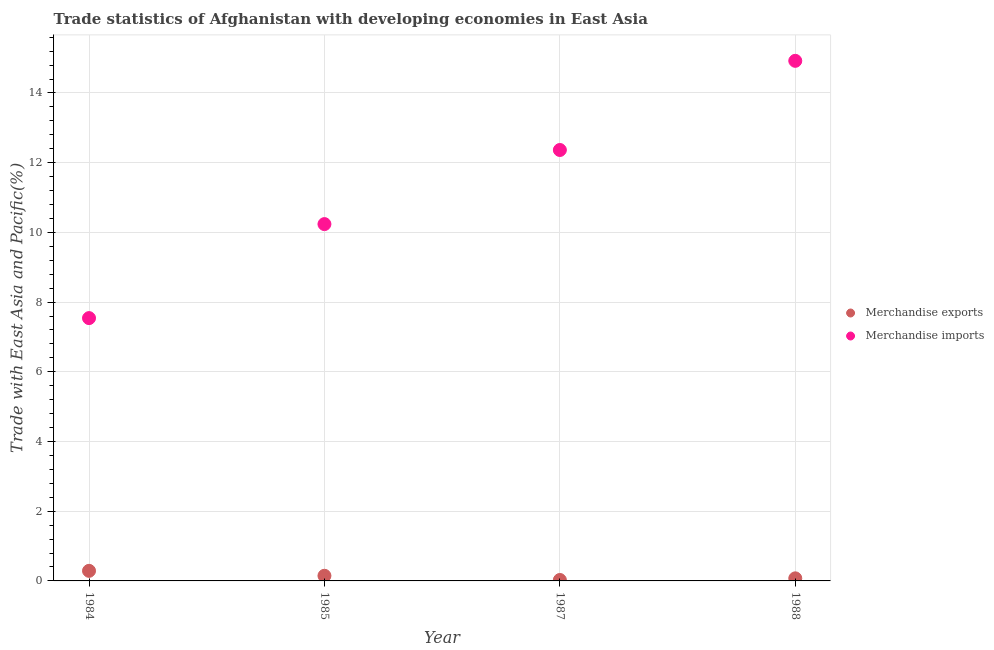How many different coloured dotlines are there?
Your answer should be very brief. 2. What is the merchandise imports in 1985?
Keep it short and to the point. 10.24. Across all years, what is the maximum merchandise exports?
Offer a terse response. 0.29. Across all years, what is the minimum merchandise imports?
Offer a very short reply. 7.54. In which year was the merchandise imports maximum?
Your answer should be compact. 1988. In which year was the merchandise exports minimum?
Give a very brief answer. 1987. What is the total merchandise exports in the graph?
Ensure brevity in your answer.  0.54. What is the difference between the merchandise exports in 1985 and that in 1987?
Ensure brevity in your answer.  0.12. What is the difference between the merchandise imports in 1985 and the merchandise exports in 1984?
Provide a succinct answer. 9.95. What is the average merchandise imports per year?
Your answer should be compact. 11.27. In the year 1985, what is the difference between the merchandise imports and merchandise exports?
Your answer should be compact. 10.09. What is the ratio of the merchandise imports in 1984 to that in 1985?
Give a very brief answer. 0.74. Is the merchandise imports in 1985 less than that in 1987?
Offer a very short reply. Yes. What is the difference between the highest and the second highest merchandise exports?
Offer a terse response. 0.14. What is the difference between the highest and the lowest merchandise imports?
Keep it short and to the point. 7.38. Does the merchandise imports monotonically increase over the years?
Keep it short and to the point. Yes. Is the merchandise imports strictly greater than the merchandise exports over the years?
Offer a very short reply. Yes. Is the merchandise imports strictly less than the merchandise exports over the years?
Provide a short and direct response. No. How many dotlines are there?
Your response must be concise. 2. What is the difference between two consecutive major ticks on the Y-axis?
Your response must be concise. 2. Does the graph contain any zero values?
Your response must be concise. No. Where does the legend appear in the graph?
Your answer should be very brief. Center right. How many legend labels are there?
Offer a terse response. 2. How are the legend labels stacked?
Offer a very short reply. Vertical. What is the title of the graph?
Your response must be concise. Trade statistics of Afghanistan with developing economies in East Asia. What is the label or title of the X-axis?
Make the answer very short. Year. What is the label or title of the Y-axis?
Provide a short and direct response. Trade with East Asia and Pacific(%). What is the Trade with East Asia and Pacific(%) in Merchandise exports in 1984?
Give a very brief answer. 0.29. What is the Trade with East Asia and Pacific(%) of Merchandise imports in 1984?
Offer a very short reply. 7.54. What is the Trade with East Asia and Pacific(%) of Merchandise exports in 1985?
Provide a succinct answer. 0.15. What is the Trade with East Asia and Pacific(%) of Merchandise imports in 1985?
Make the answer very short. 10.24. What is the Trade with East Asia and Pacific(%) of Merchandise exports in 1987?
Your answer should be compact. 0.03. What is the Trade with East Asia and Pacific(%) of Merchandise imports in 1987?
Your response must be concise. 12.36. What is the Trade with East Asia and Pacific(%) in Merchandise exports in 1988?
Your answer should be very brief. 0.07. What is the Trade with East Asia and Pacific(%) of Merchandise imports in 1988?
Give a very brief answer. 14.92. Across all years, what is the maximum Trade with East Asia and Pacific(%) in Merchandise exports?
Keep it short and to the point. 0.29. Across all years, what is the maximum Trade with East Asia and Pacific(%) in Merchandise imports?
Your answer should be compact. 14.92. Across all years, what is the minimum Trade with East Asia and Pacific(%) of Merchandise exports?
Your answer should be compact. 0.03. Across all years, what is the minimum Trade with East Asia and Pacific(%) of Merchandise imports?
Ensure brevity in your answer.  7.54. What is the total Trade with East Asia and Pacific(%) in Merchandise exports in the graph?
Your response must be concise. 0.54. What is the total Trade with East Asia and Pacific(%) of Merchandise imports in the graph?
Ensure brevity in your answer.  45.06. What is the difference between the Trade with East Asia and Pacific(%) of Merchandise exports in 1984 and that in 1985?
Provide a succinct answer. 0.14. What is the difference between the Trade with East Asia and Pacific(%) of Merchandise imports in 1984 and that in 1985?
Your response must be concise. -2.7. What is the difference between the Trade with East Asia and Pacific(%) in Merchandise exports in 1984 and that in 1987?
Offer a terse response. 0.26. What is the difference between the Trade with East Asia and Pacific(%) of Merchandise imports in 1984 and that in 1987?
Ensure brevity in your answer.  -4.82. What is the difference between the Trade with East Asia and Pacific(%) of Merchandise exports in 1984 and that in 1988?
Keep it short and to the point. 0.22. What is the difference between the Trade with East Asia and Pacific(%) of Merchandise imports in 1984 and that in 1988?
Keep it short and to the point. -7.38. What is the difference between the Trade with East Asia and Pacific(%) of Merchandise exports in 1985 and that in 1987?
Your response must be concise. 0.12. What is the difference between the Trade with East Asia and Pacific(%) of Merchandise imports in 1985 and that in 1987?
Ensure brevity in your answer.  -2.13. What is the difference between the Trade with East Asia and Pacific(%) of Merchandise exports in 1985 and that in 1988?
Provide a succinct answer. 0.07. What is the difference between the Trade with East Asia and Pacific(%) in Merchandise imports in 1985 and that in 1988?
Offer a terse response. -4.68. What is the difference between the Trade with East Asia and Pacific(%) in Merchandise exports in 1987 and that in 1988?
Offer a very short reply. -0.05. What is the difference between the Trade with East Asia and Pacific(%) of Merchandise imports in 1987 and that in 1988?
Give a very brief answer. -2.56. What is the difference between the Trade with East Asia and Pacific(%) of Merchandise exports in 1984 and the Trade with East Asia and Pacific(%) of Merchandise imports in 1985?
Give a very brief answer. -9.95. What is the difference between the Trade with East Asia and Pacific(%) in Merchandise exports in 1984 and the Trade with East Asia and Pacific(%) in Merchandise imports in 1987?
Make the answer very short. -12.07. What is the difference between the Trade with East Asia and Pacific(%) of Merchandise exports in 1984 and the Trade with East Asia and Pacific(%) of Merchandise imports in 1988?
Offer a terse response. -14.63. What is the difference between the Trade with East Asia and Pacific(%) of Merchandise exports in 1985 and the Trade with East Asia and Pacific(%) of Merchandise imports in 1987?
Give a very brief answer. -12.22. What is the difference between the Trade with East Asia and Pacific(%) of Merchandise exports in 1985 and the Trade with East Asia and Pacific(%) of Merchandise imports in 1988?
Ensure brevity in your answer.  -14.77. What is the difference between the Trade with East Asia and Pacific(%) of Merchandise exports in 1987 and the Trade with East Asia and Pacific(%) of Merchandise imports in 1988?
Ensure brevity in your answer.  -14.9. What is the average Trade with East Asia and Pacific(%) in Merchandise exports per year?
Offer a terse response. 0.13. What is the average Trade with East Asia and Pacific(%) in Merchandise imports per year?
Keep it short and to the point. 11.27. In the year 1984, what is the difference between the Trade with East Asia and Pacific(%) of Merchandise exports and Trade with East Asia and Pacific(%) of Merchandise imports?
Offer a terse response. -7.25. In the year 1985, what is the difference between the Trade with East Asia and Pacific(%) in Merchandise exports and Trade with East Asia and Pacific(%) in Merchandise imports?
Give a very brief answer. -10.09. In the year 1987, what is the difference between the Trade with East Asia and Pacific(%) in Merchandise exports and Trade with East Asia and Pacific(%) in Merchandise imports?
Your answer should be very brief. -12.34. In the year 1988, what is the difference between the Trade with East Asia and Pacific(%) in Merchandise exports and Trade with East Asia and Pacific(%) in Merchandise imports?
Your response must be concise. -14.85. What is the ratio of the Trade with East Asia and Pacific(%) of Merchandise exports in 1984 to that in 1985?
Offer a terse response. 1.96. What is the ratio of the Trade with East Asia and Pacific(%) of Merchandise imports in 1984 to that in 1985?
Give a very brief answer. 0.74. What is the ratio of the Trade with East Asia and Pacific(%) in Merchandise exports in 1984 to that in 1987?
Offer a terse response. 10.7. What is the ratio of the Trade with East Asia and Pacific(%) in Merchandise imports in 1984 to that in 1987?
Your response must be concise. 0.61. What is the ratio of the Trade with East Asia and Pacific(%) in Merchandise exports in 1984 to that in 1988?
Provide a short and direct response. 3.9. What is the ratio of the Trade with East Asia and Pacific(%) of Merchandise imports in 1984 to that in 1988?
Provide a short and direct response. 0.51. What is the ratio of the Trade with East Asia and Pacific(%) in Merchandise exports in 1985 to that in 1987?
Offer a terse response. 5.46. What is the ratio of the Trade with East Asia and Pacific(%) of Merchandise imports in 1985 to that in 1987?
Your answer should be very brief. 0.83. What is the ratio of the Trade with East Asia and Pacific(%) of Merchandise exports in 1985 to that in 1988?
Your answer should be compact. 1.99. What is the ratio of the Trade with East Asia and Pacific(%) in Merchandise imports in 1985 to that in 1988?
Ensure brevity in your answer.  0.69. What is the ratio of the Trade with East Asia and Pacific(%) of Merchandise exports in 1987 to that in 1988?
Provide a succinct answer. 0.36. What is the ratio of the Trade with East Asia and Pacific(%) in Merchandise imports in 1987 to that in 1988?
Offer a terse response. 0.83. What is the difference between the highest and the second highest Trade with East Asia and Pacific(%) in Merchandise exports?
Provide a short and direct response. 0.14. What is the difference between the highest and the second highest Trade with East Asia and Pacific(%) of Merchandise imports?
Make the answer very short. 2.56. What is the difference between the highest and the lowest Trade with East Asia and Pacific(%) in Merchandise exports?
Your answer should be compact. 0.26. What is the difference between the highest and the lowest Trade with East Asia and Pacific(%) of Merchandise imports?
Offer a very short reply. 7.38. 